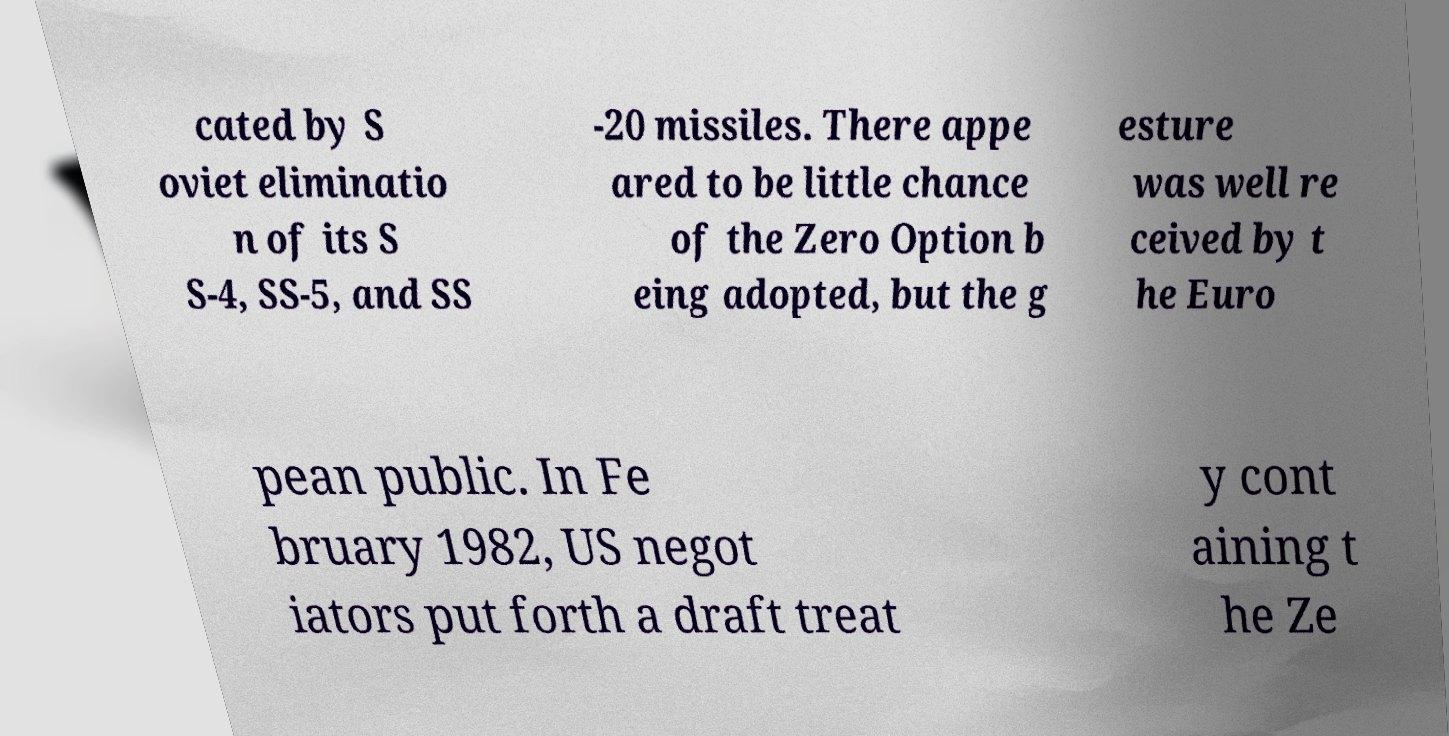There's text embedded in this image that I need extracted. Can you transcribe it verbatim? cated by S oviet eliminatio n of its S S-4, SS-5, and SS -20 missiles. There appe ared to be little chance of the Zero Option b eing adopted, but the g esture was well re ceived by t he Euro pean public. In Fe bruary 1982, US negot iators put forth a draft treat y cont aining t he Ze 